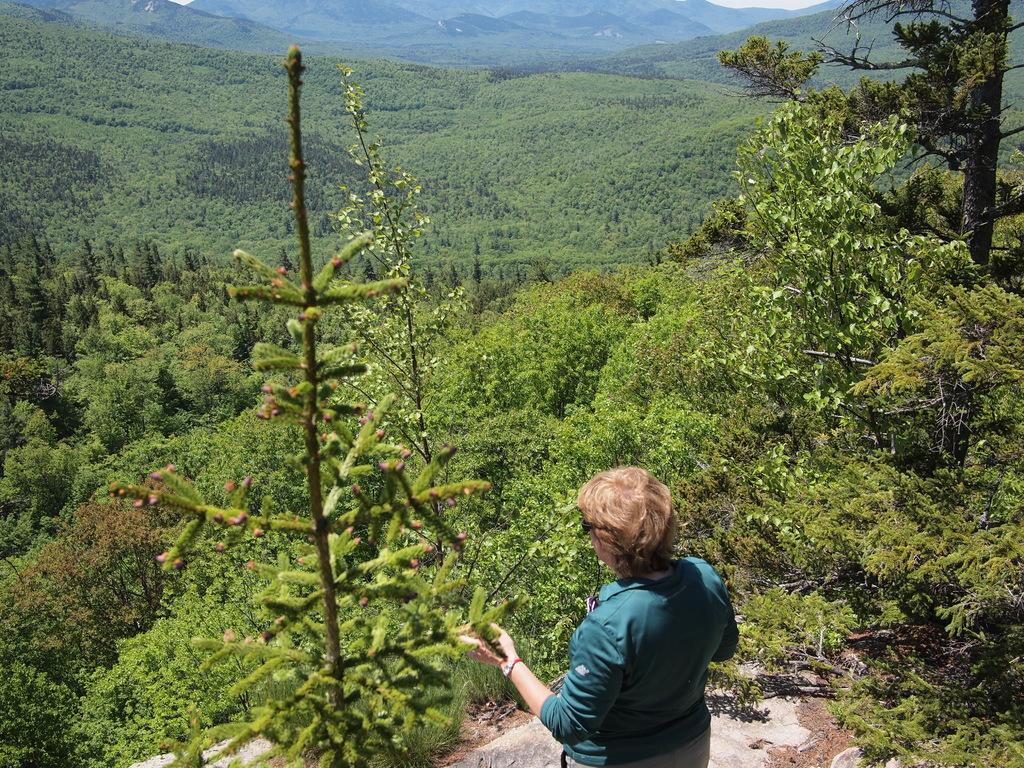Describe this image in one or two sentences. In this picture there is a person standing and we can see trees and hill. 